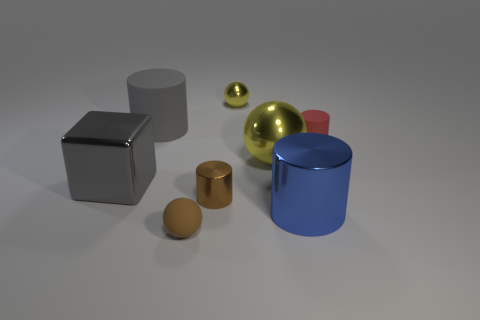What can the arrangement of these objects tell us about the purpose of the image? The arrangement of these objects in an orderly fashion with adequate spacing between them suggests that the image is meant for demonstration purposes, possibly showcasing the objects' geometric shapes, materials, and light reflection properties in a controlled setting. 